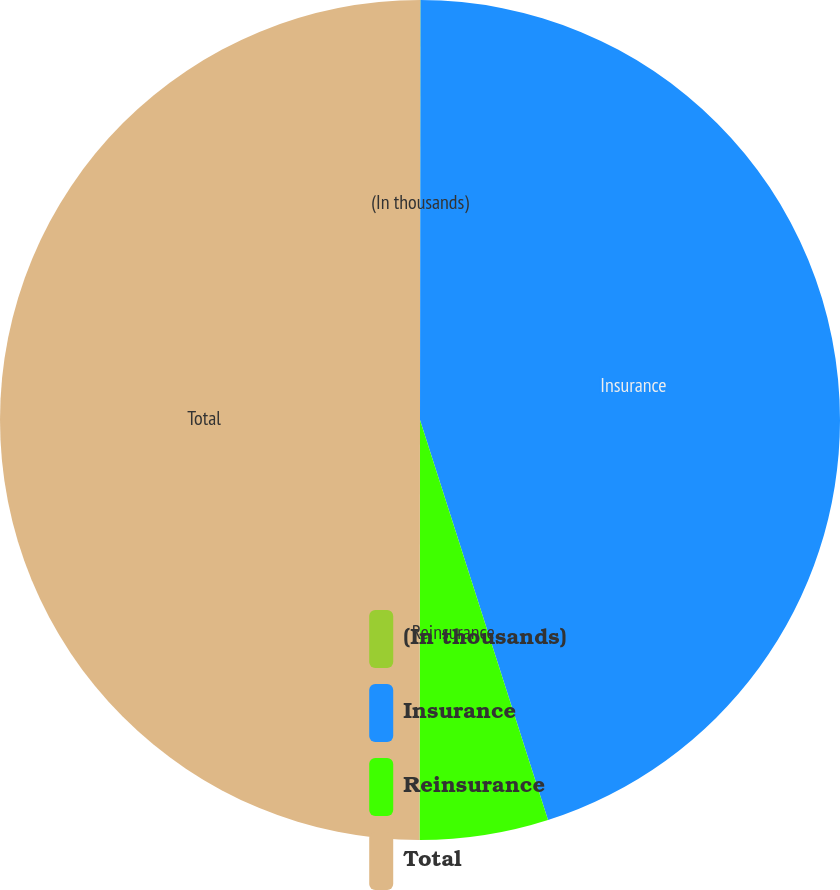<chart> <loc_0><loc_0><loc_500><loc_500><pie_chart><fcel>(In thousands)<fcel>Insurance<fcel>Reinsurance<fcel>Total<nl><fcel>0.02%<fcel>45.05%<fcel>4.95%<fcel>49.98%<nl></chart> 